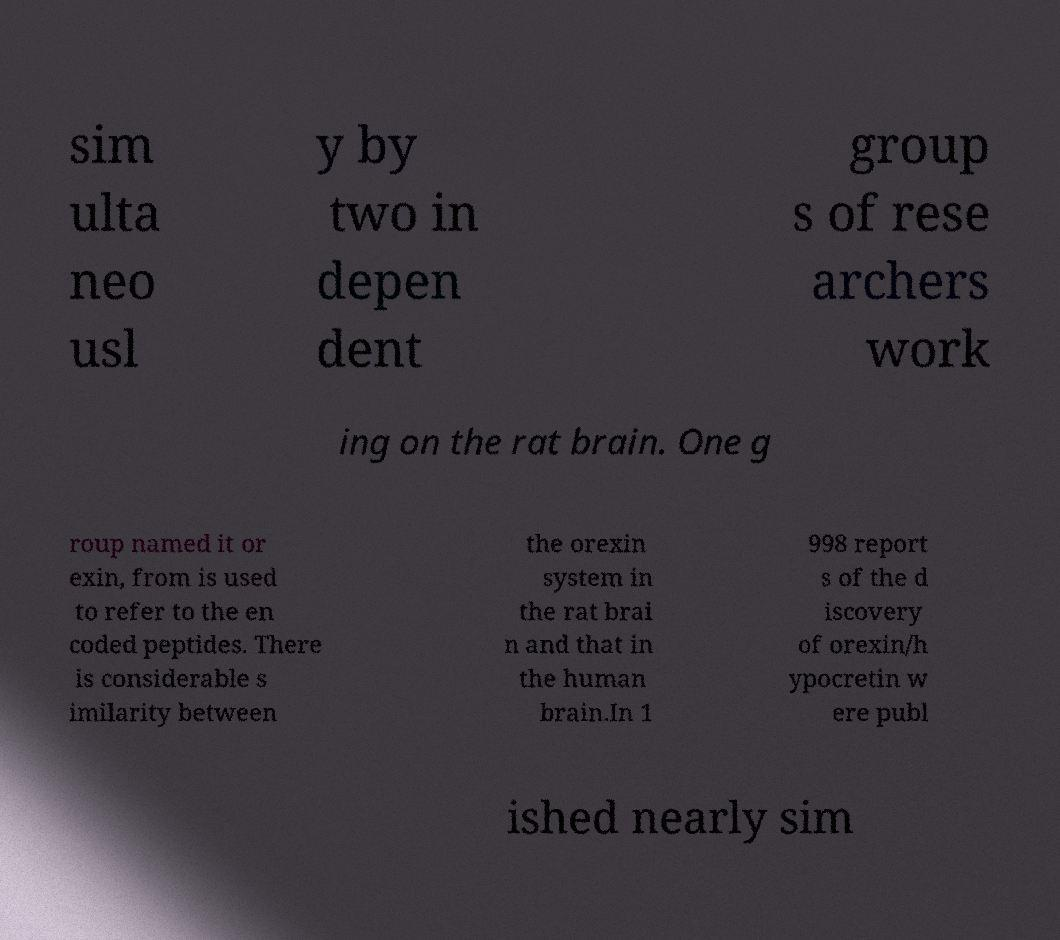Please read and relay the text visible in this image. What does it say? sim ulta neo usl y by two in depen dent group s of rese archers work ing on the rat brain. One g roup named it or exin, from is used to refer to the en coded peptides. There is considerable s imilarity between the orexin system in the rat brai n and that in the human brain.In 1 998 report s of the d iscovery of orexin/h ypocretin w ere publ ished nearly sim 